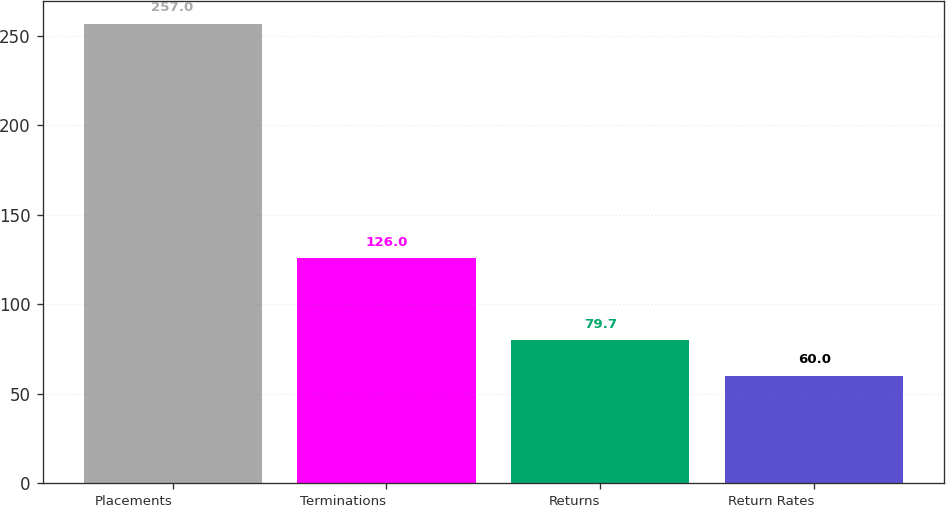Convert chart. <chart><loc_0><loc_0><loc_500><loc_500><bar_chart><fcel>Placements<fcel>Terminations<fcel>Returns<fcel>Return Rates<nl><fcel>257<fcel>126<fcel>79.7<fcel>60<nl></chart> 